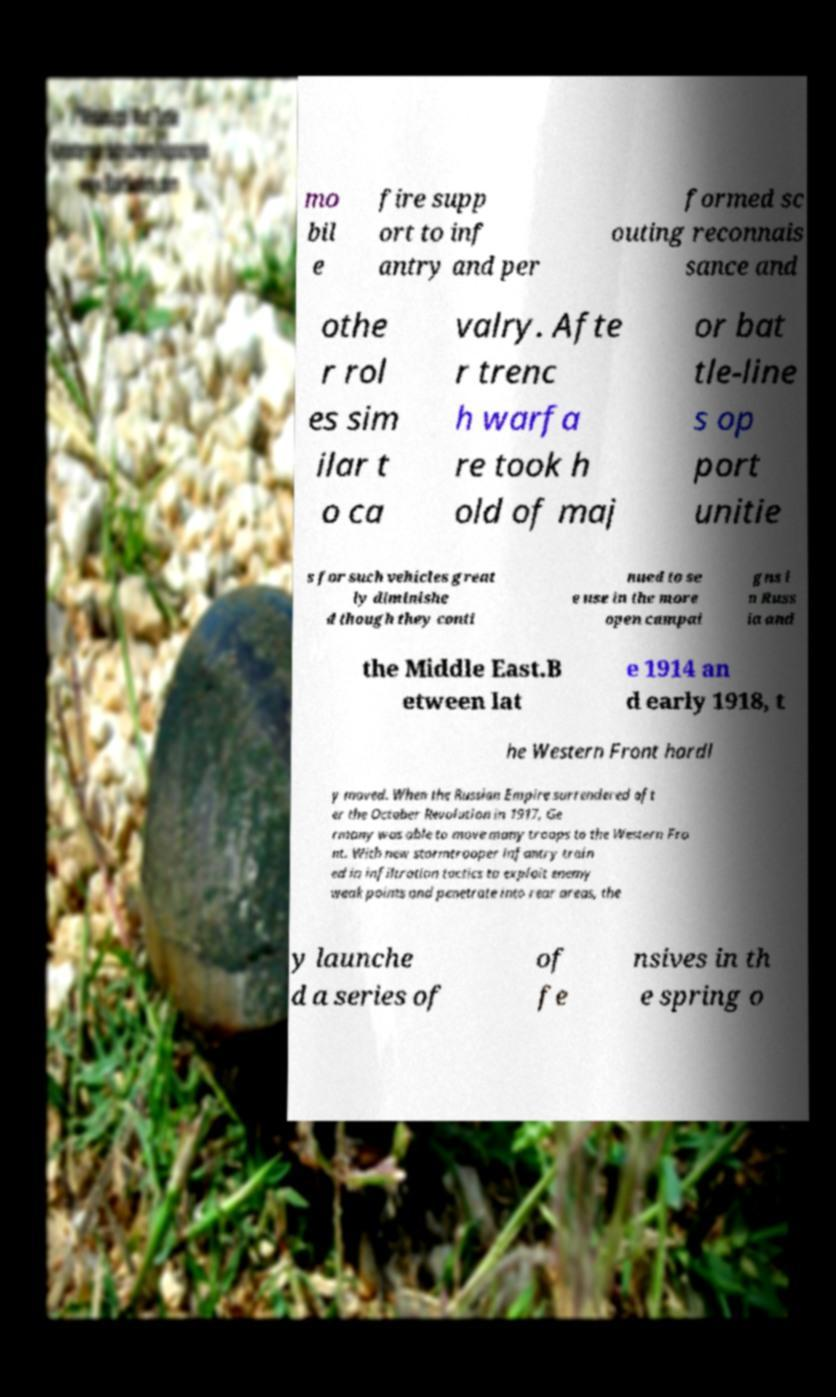What messages or text are displayed in this image? I need them in a readable, typed format. mo bil e fire supp ort to inf antry and per formed sc outing reconnais sance and othe r rol es sim ilar t o ca valry. Afte r trenc h warfa re took h old of maj or bat tle-line s op port unitie s for such vehicles great ly diminishe d though they conti nued to se e use in the more open campai gns i n Russ ia and the Middle East.B etween lat e 1914 an d early 1918, t he Western Front hardl y moved. When the Russian Empire surrendered aft er the October Revolution in 1917, Ge rmany was able to move many troops to the Western Fro nt. With new stormtrooper infantry train ed in infiltration tactics to exploit enemy weak points and penetrate into rear areas, the y launche d a series of of fe nsives in th e spring o 